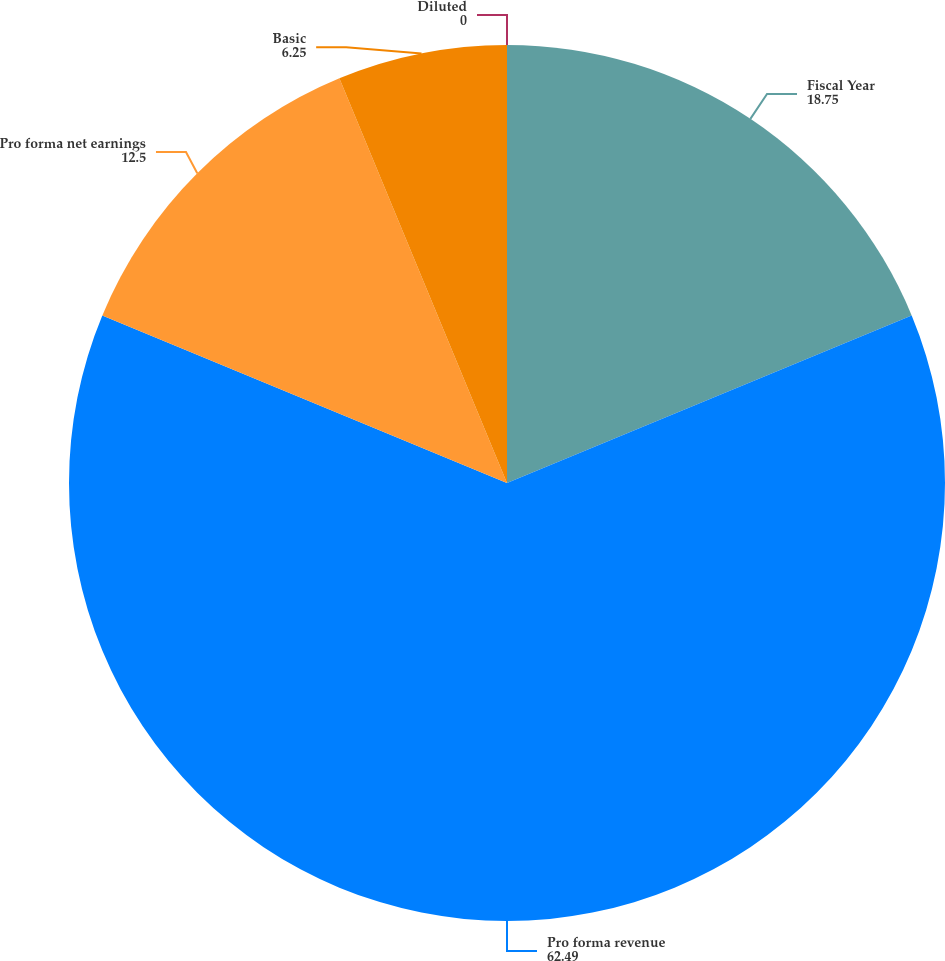Convert chart. <chart><loc_0><loc_0><loc_500><loc_500><pie_chart><fcel>Fiscal Year<fcel>Pro forma revenue<fcel>Pro forma net earnings<fcel>Basic<fcel>Diluted<nl><fcel>18.75%<fcel>62.49%<fcel>12.5%<fcel>6.25%<fcel>0.0%<nl></chart> 